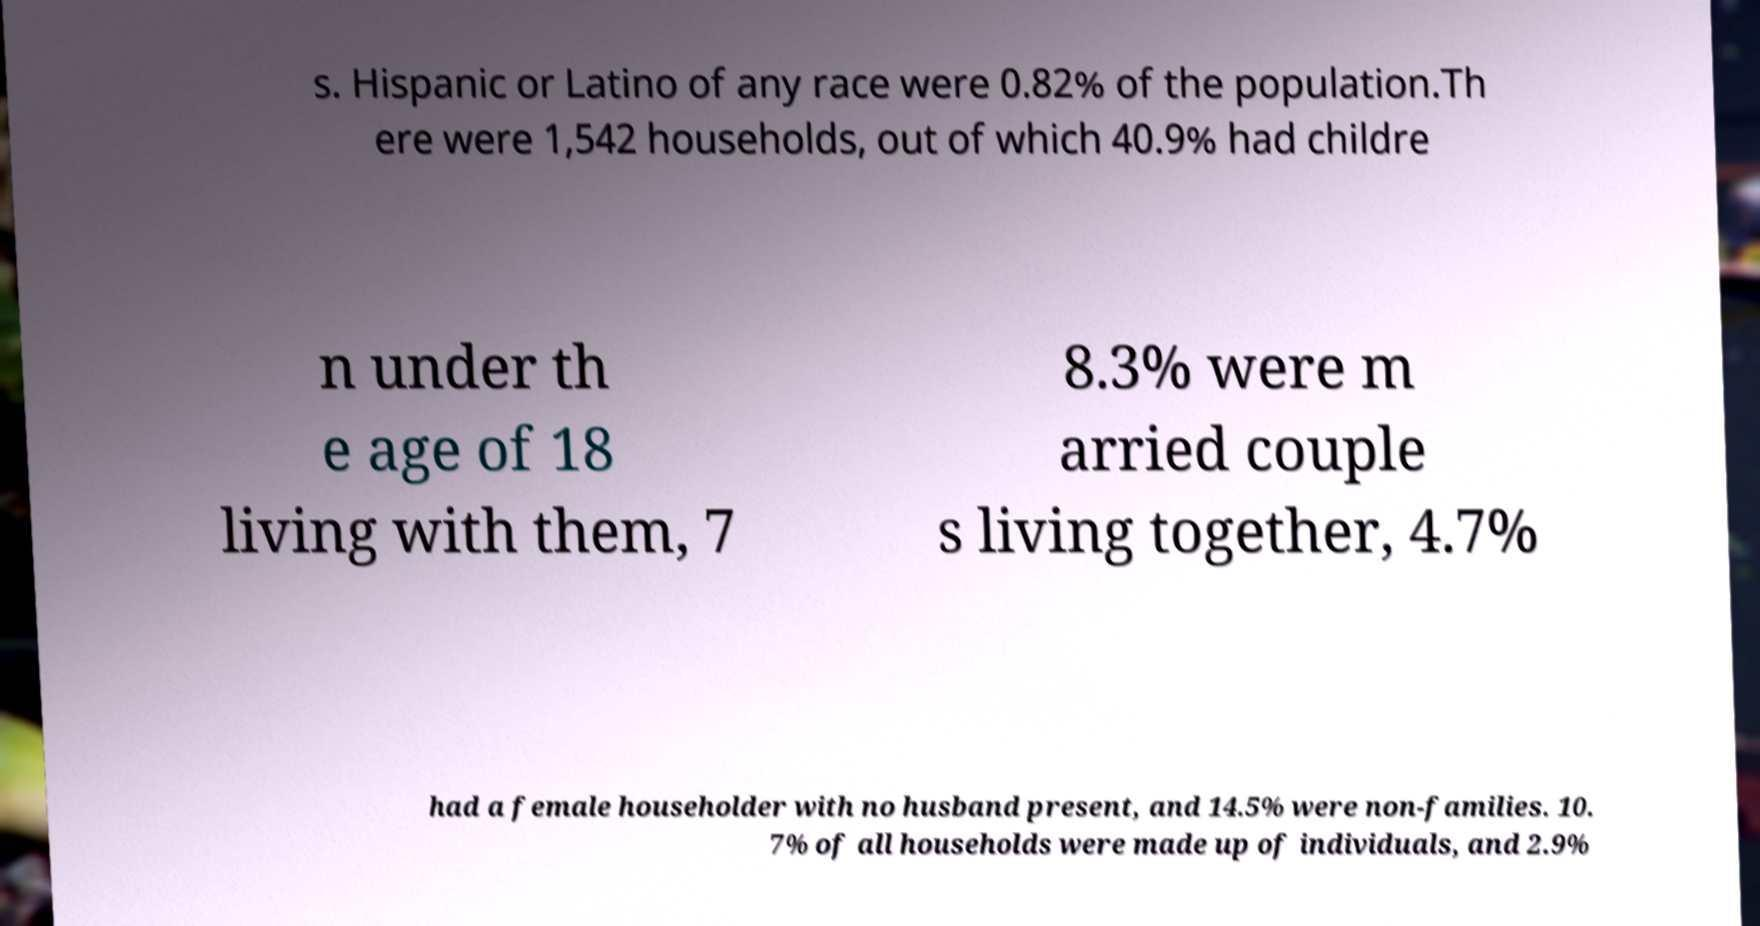Please identify and transcribe the text found in this image. s. Hispanic or Latino of any race were 0.82% of the population.Th ere were 1,542 households, out of which 40.9% had childre n under th e age of 18 living with them, 7 8.3% were m arried couple s living together, 4.7% had a female householder with no husband present, and 14.5% were non-families. 10. 7% of all households were made up of individuals, and 2.9% 